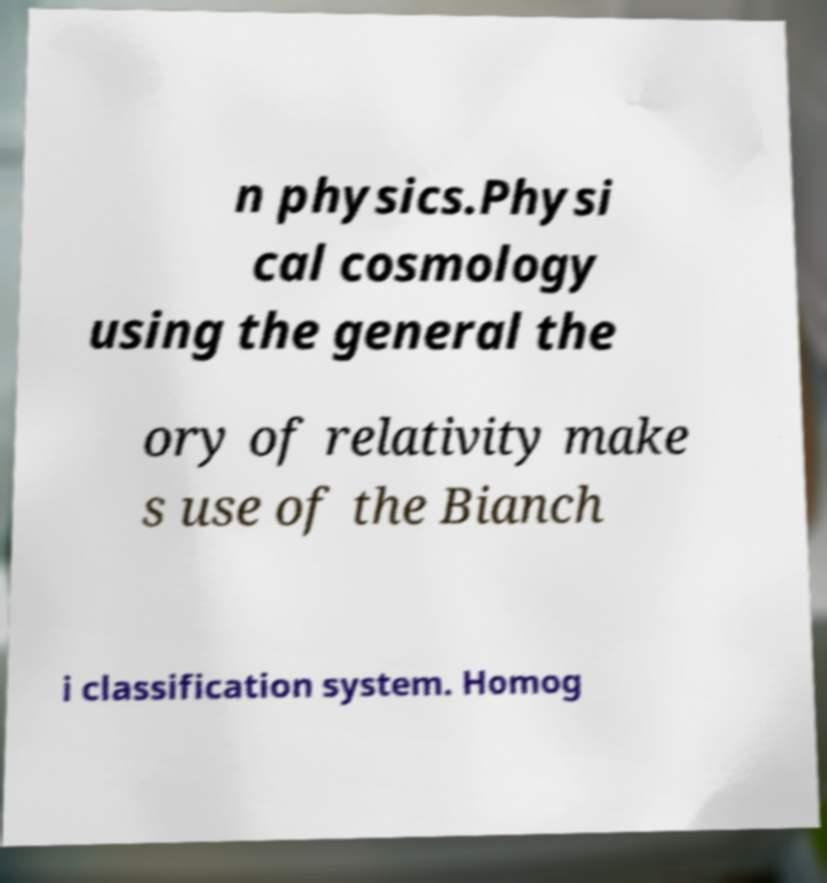For documentation purposes, I need the text within this image transcribed. Could you provide that? n physics.Physi cal cosmology using the general the ory of relativity make s use of the Bianch i classification system. Homog 